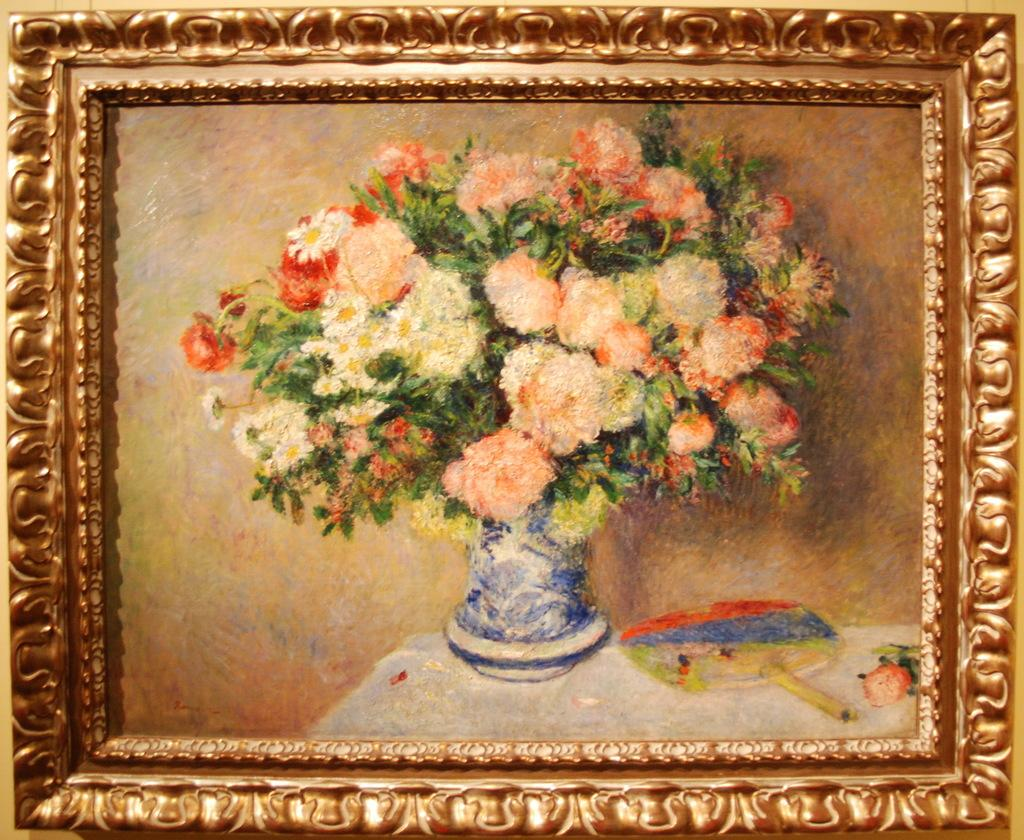What type of artwork is visible in the image? There are portraits in the image. What is located on a table in the image? There is a flower pot on a table in the image. What type of dishware is present in the image? There is a plate present in the image. What type of money is depicted in the portraits in the image? There is no money depicted in the portraits in the image; they are portraits of people or objects. 